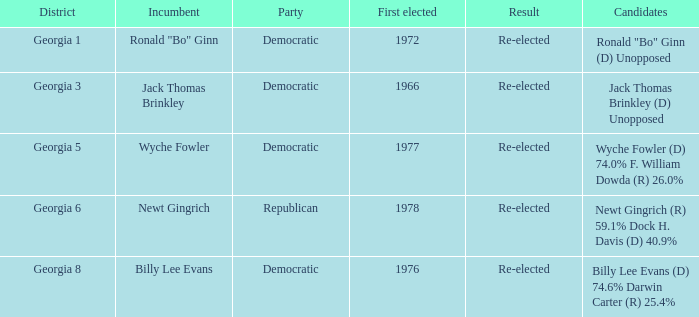1% and dock h. davis (d) 4 1.0. 